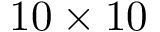<formula> <loc_0><loc_0><loc_500><loc_500>1 0 \times 1 0</formula> 